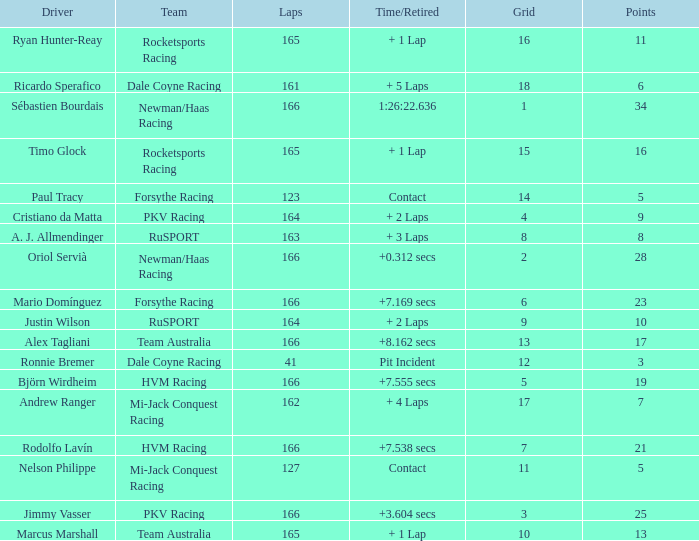Driver Ricardo Sperafico has what as his average laps? 161.0. 